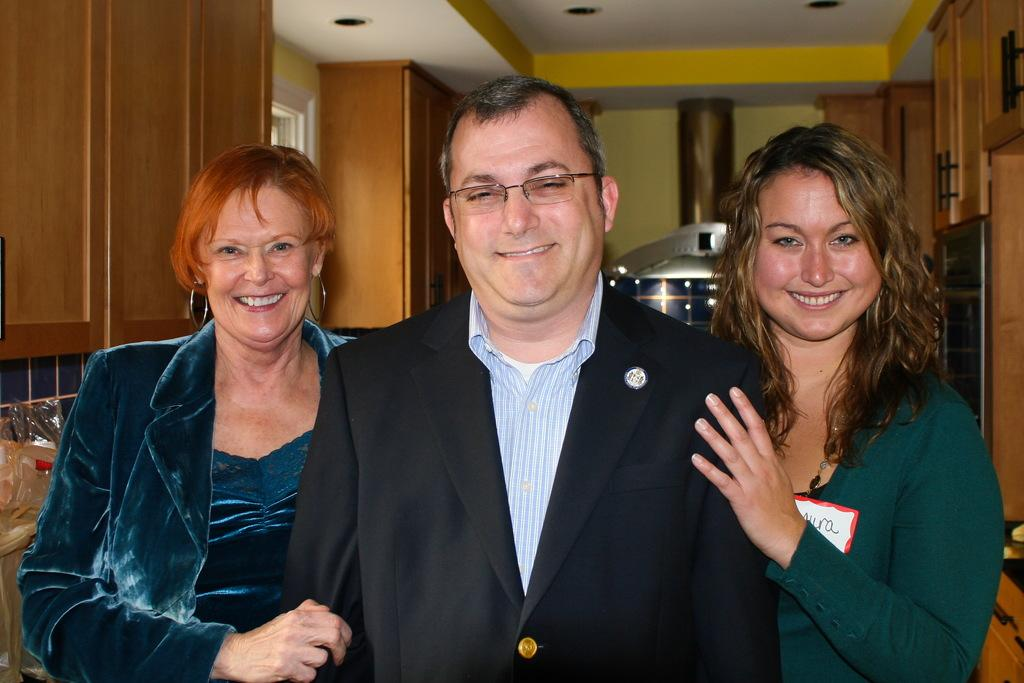How many people are in the image? There are three individuals in the image: one man and two women. What is the facial expression of the people in the image? All three individuals are smiling. What type of structure is visible in the image? There is a building and a roof visible in the image. Can you describe any architectural features in the image? There is a wall visible in the image. What type of quill is the man using to write on the wall in the image? There is no quill or writing activity present in the image. Can you see any blood on the fork in the image? There is no fork or blood present in the image. 